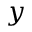<formula> <loc_0><loc_0><loc_500><loc_500>y</formula> 